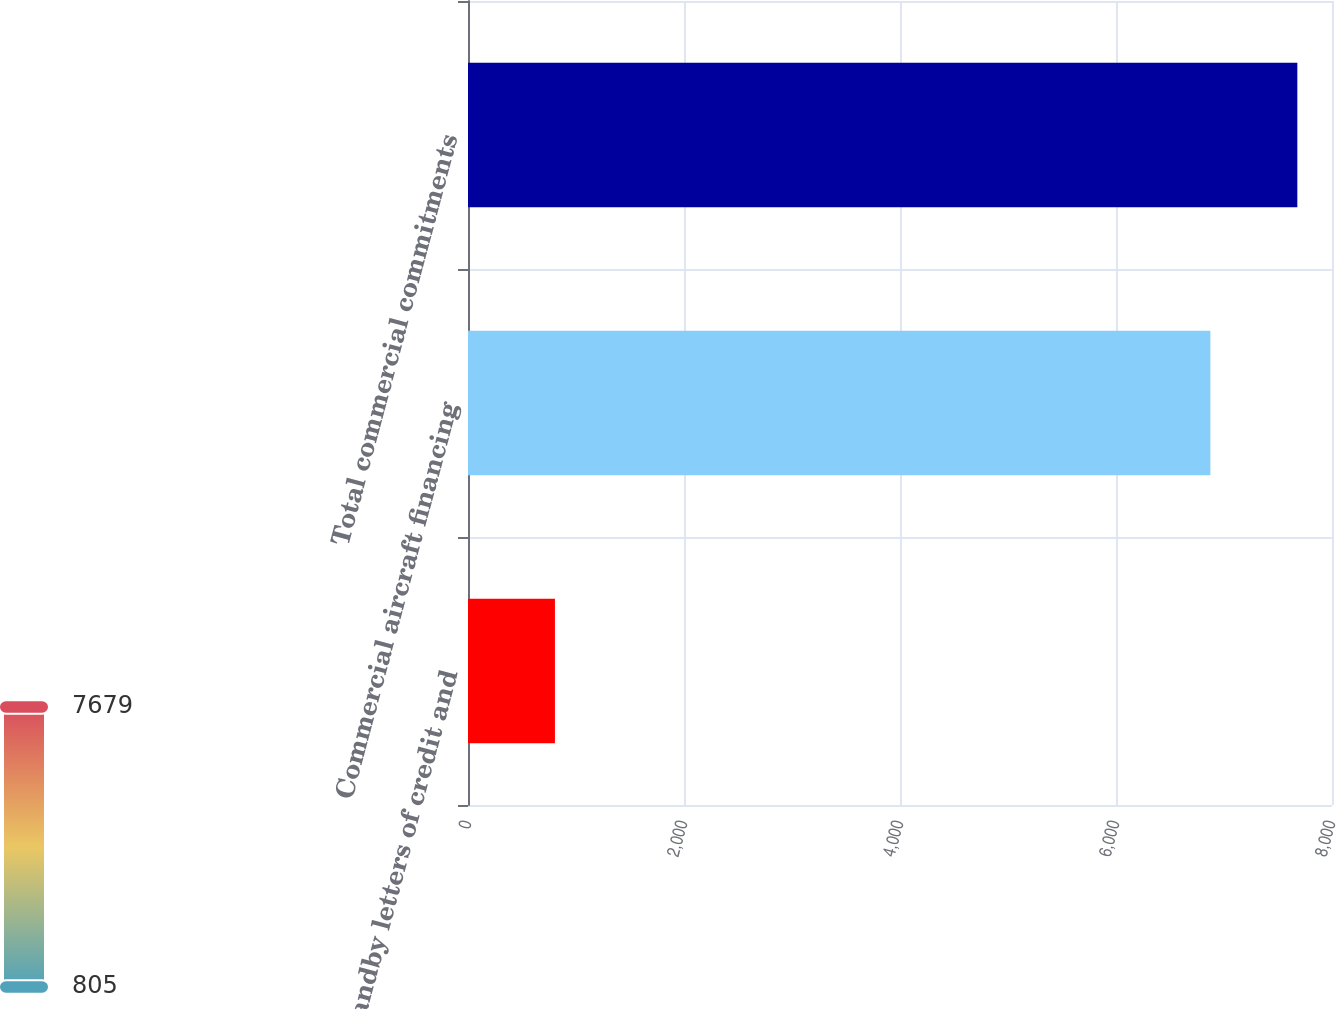Convert chart to OTSL. <chart><loc_0><loc_0><loc_500><loc_500><bar_chart><fcel>Standby letters of credit and<fcel>Commercial aircraft financing<fcel>Total commercial commitments<nl><fcel>805<fcel>6874<fcel>7679<nl></chart> 